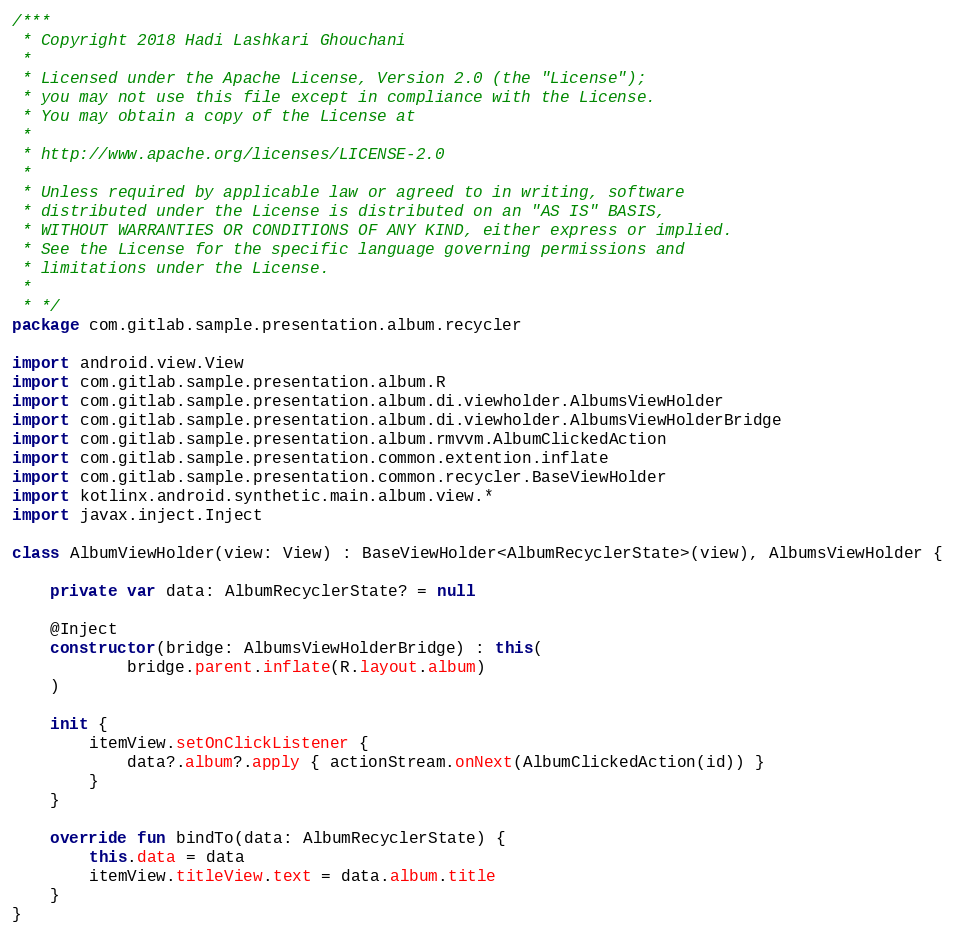<code> <loc_0><loc_0><loc_500><loc_500><_Kotlin_>/***
 * Copyright 2018 Hadi Lashkari Ghouchani
 *
 * Licensed under the Apache License, Version 2.0 (the "License");
 * you may not use this file except in compliance with the License.
 * You may obtain a copy of the License at
 *
 * http://www.apache.org/licenses/LICENSE-2.0
 *
 * Unless required by applicable law or agreed to in writing, software
 * distributed under the License is distributed on an "AS IS" BASIS,
 * WITHOUT WARRANTIES OR CONDITIONS OF ANY KIND, either express or implied.
 * See the License for the specific language governing permissions and
 * limitations under the License.
 *
 * */
package com.gitlab.sample.presentation.album.recycler

import android.view.View
import com.gitlab.sample.presentation.album.R
import com.gitlab.sample.presentation.album.di.viewholder.AlbumsViewHolder
import com.gitlab.sample.presentation.album.di.viewholder.AlbumsViewHolderBridge
import com.gitlab.sample.presentation.album.rmvvm.AlbumClickedAction
import com.gitlab.sample.presentation.common.extention.inflate
import com.gitlab.sample.presentation.common.recycler.BaseViewHolder
import kotlinx.android.synthetic.main.album.view.*
import javax.inject.Inject

class AlbumViewHolder(view: View) : BaseViewHolder<AlbumRecyclerState>(view), AlbumsViewHolder {

    private var data: AlbumRecyclerState? = null

    @Inject
    constructor(bridge: AlbumsViewHolderBridge) : this(
            bridge.parent.inflate(R.layout.album)
    )

    init {
        itemView.setOnClickListener {
            data?.album?.apply { actionStream.onNext(AlbumClickedAction(id)) }
        }
    }

    override fun bindTo(data: AlbumRecyclerState) {
        this.data = data
        itemView.titleView.text = data.album.title
    }
}</code> 